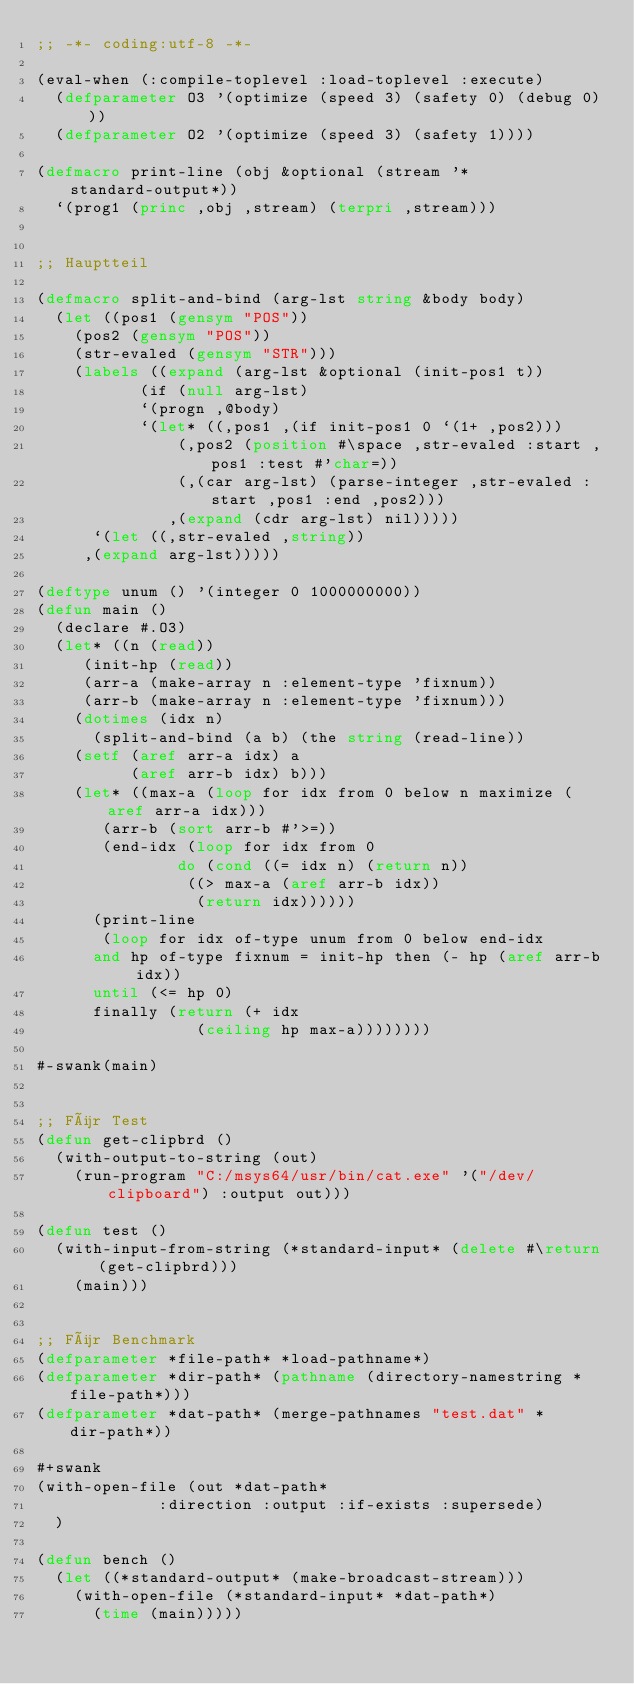<code> <loc_0><loc_0><loc_500><loc_500><_Lisp_>;; -*- coding:utf-8 -*-

(eval-when (:compile-toplevel :load-toplevel :execute)
  (defparameter O3 '(optimize (speed 3) (safety 0) (debug 0)))
  (defparameter O2 '(optimize (speed 3) (safety 1))))

(defmacro print-line (obj &optional (stream '*standard-output*))
  `(prog1 (princ ,obj ,stream) (terpri ,stream)))


;; Hauptteil

(defmacro split-and-bind (arg-lst string &body body)
  (let ((pos1 (gensym "POS"))
	(pos2 (gensym "POS"))
	(str-evaled (gensym "STR")))
    (labels ((expand (arg-lst &optional (init-pos1 t))
	       (if (null arg-lst)
		   `(progn ,@body)
		   `(let* ((,pos1 ,(if init-pos1 0 `(1+ ,pos2)))
			   (,pos2 (position #\space ,str-evaled :start ,pos1 :test #'char=))
			   (,(car arg-lst) (parse-integer ,str-evaled :start ,pos1 :end ,pos2)))
		      ,(expand (cdr arg-lst) nil)))))
      `(let ((,str-evaled ,string))
	 ,(expand arg-lst)))))

(deftype unum () '(integer 0 1000000000))
(defun main ()
  (declare #.O3)
  (let* ((n (read))
	 (init-hp (read))
	 (arr-a (make-array n :element-type 'fixnum))
	 (arr-b (make-array n :element-type 'fixnum)))
    (dotimes (idx n)
      (split-and-bind (a b) (the string (read-line))
	(setf (aref arr-a idx) a
	      (aref arr-b idx) b)))
    (let* ((max-a (loop for idx from 0 below n maximize (aref arr-a idx)))
	   (arr-b (sort arr-b #'>=))
	   (end-idx (loop for idx from 0
		       do (cond ((= idx n) (return n))
				((> max-a (aref arr-b idx))
				 (return idx))))))
      (print-line
       (loop for idx of-type unum from 0 below end-idx
	  and hp of-type fixnum = init-hp then (- hp (aref arr-b idx))
	  until (<= hp 0)
	  finally (return (+ idx
			     (ceiling hp max-a))))))))

#-swank(main)


;; Für Test
(defun get-clipbrd ()
  (with-output-to-string (out)
    (run-program "C:/msys64/usr/bin/cat.exe" '("/dev/clipboard") :output out)))

(defun test ()
  (with-input-from-string (*standard-input* (delete #\return (get-clipbrd)))
    (main)))


;; Für Benchmark
(defparameter *file-path* *load-pathname*)
(defparameter *dir-path* (pathname (directory-namestring *file-path*)))
(defparameter *dat-path* (merge-pathnames "test.dat" *dir-path*))

#+swank
(with-open-file (out *dat-path*
		     :direction :output :if-exists :supersede)
  )

(defun bench ()
  (let ((*standard-output* (make-broadcast-stream)))
    (with-open-file (*standard-input* *dat-path*)
      (time (main)))))
</code> 